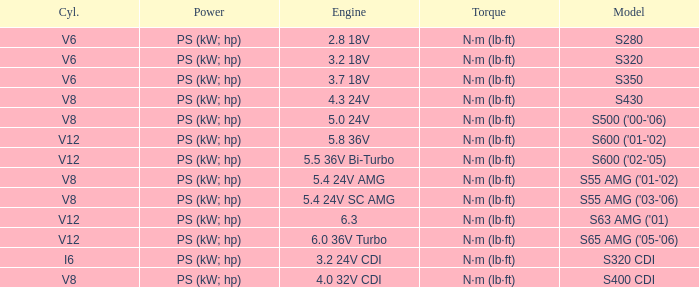Which Engine has a Model of s320 cdi? 3.2 24V CDI. 